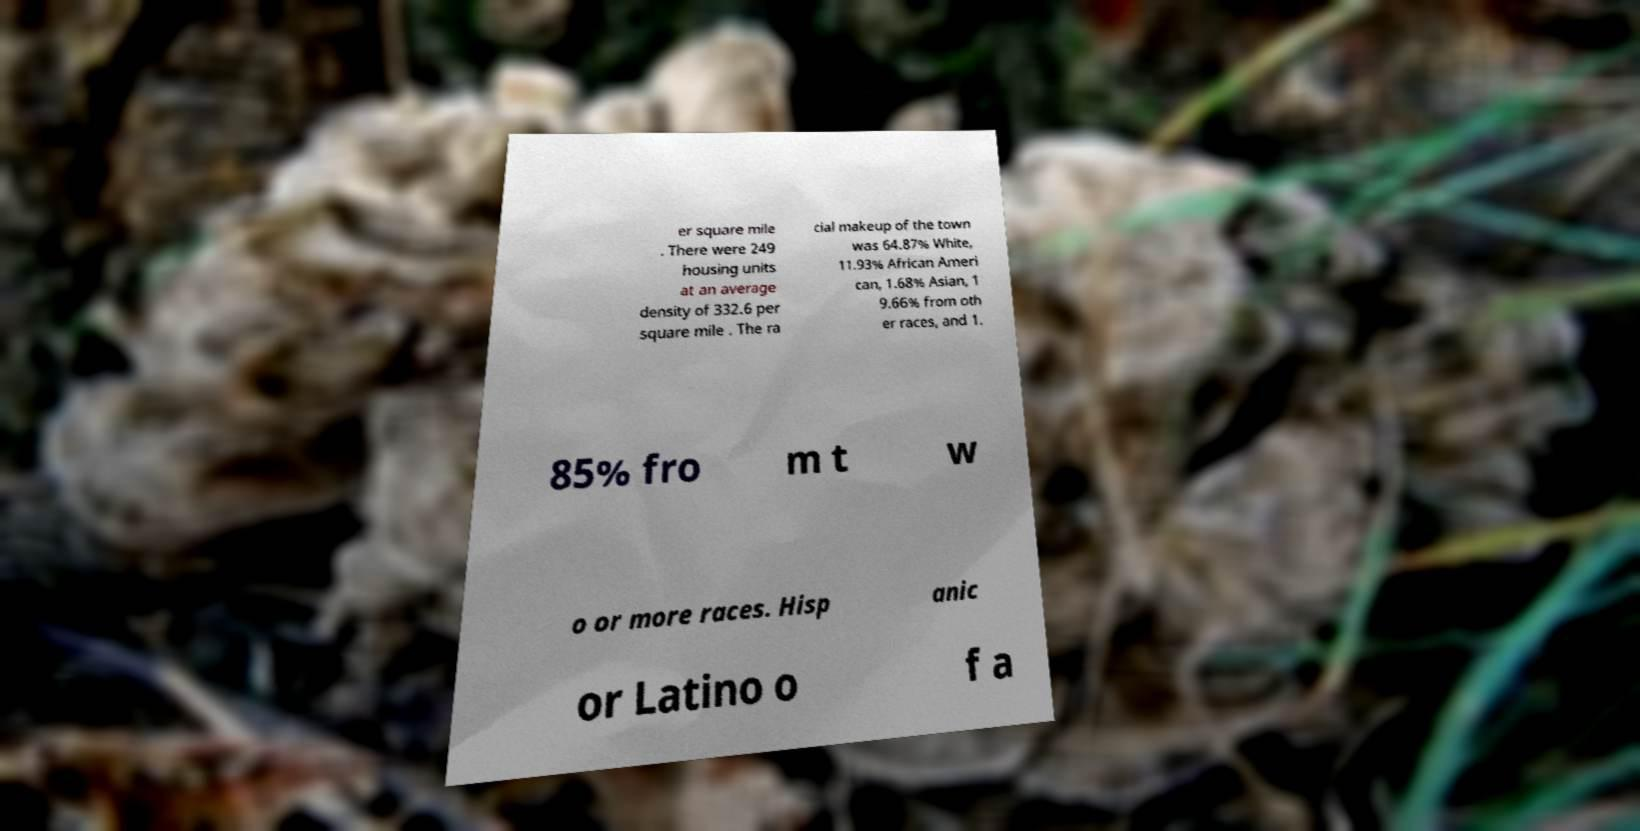For documentation purposes, I need the text within this image transcribed. Could you provide that? er square mile . There were 249 housing units at an average density of 332.6 per square mile . The ra cial makeup of the town was 64.87% White, 11.93% African Ameri can, 1.68% Asian, 1 9.66% from oth er races, and 1. 85% fro m t w o or more races. Hisp anic or Latino o f a 